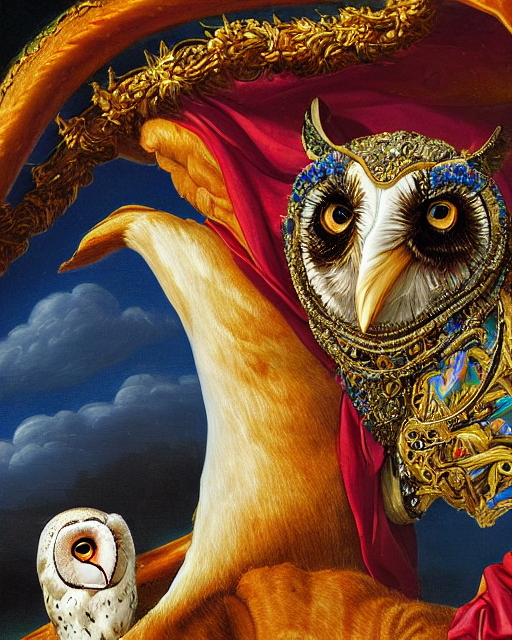What details in this image could tell us more about the time period or cultural influences in which it was created? While the image is modern and surrealist in style, the detailed rendering and lavish adornments borrow heavily from baroque sensibilities, with their dramatic contrast and elaborate decoration. This blend of styles may suggest a contemporary piece with historical influences, aiming to bridge different epochs through art. 